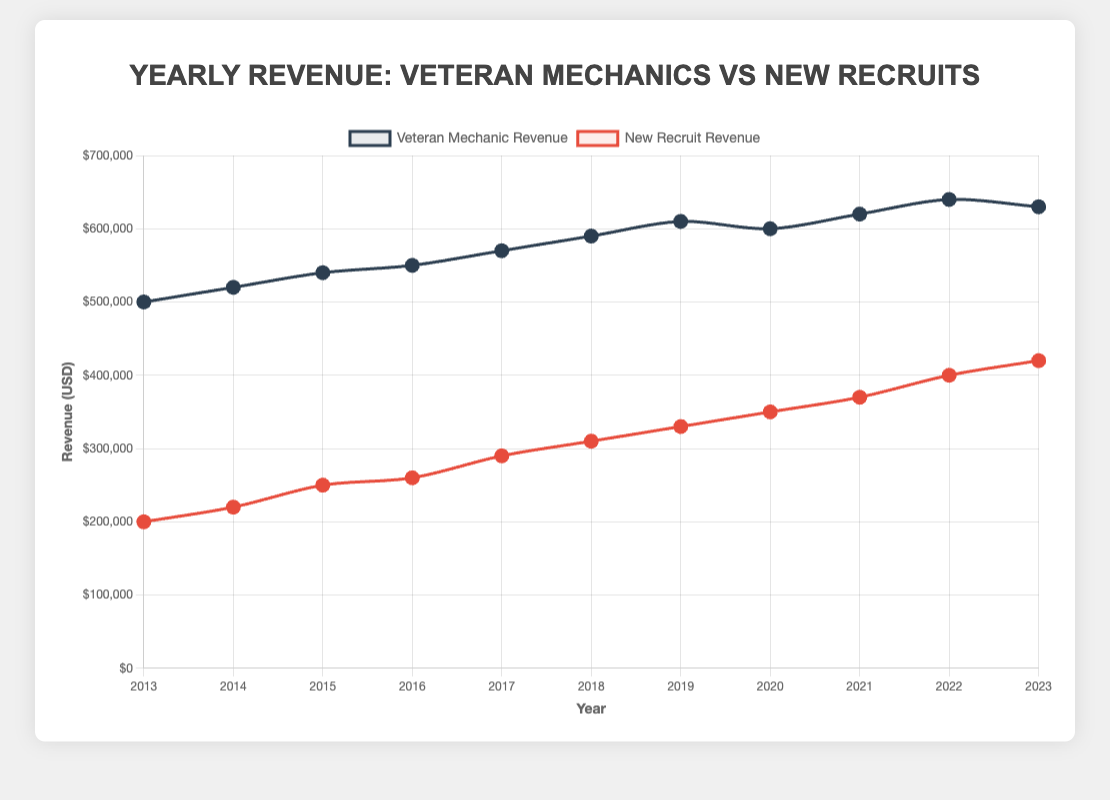Which year had the highest yearly revenue for veteran mechanics? To determine this, look at the peaks in the plot for veteran mechanics, which is represented in dark blue. The highest point reaches $640,000 in 2022.
Answer: 2022 Which group had a higher revenue in 2017, veteran mechanics or new recruits? Locate the points on the plot corresponding to 2017 for both lines. The dark blue line (veteran mechanics) is at $570,000 whereas the red line (new recruits) is at $290,000.
Answer: Veteran mechanics By how much did the revenue of new recruits increase from 2013 to 2023? Observe the values for new recruits in 2013 ($200,000) and 2023 ($420,000). Subtract the earlier year from the later year: $420,000 - $200,000 = $220,000.
Answer: $220,000 What's the average revenue generated by veteran mechanics over the 10-year span from 2013 to 2023? Calculate the sum of the yearly revenues for veteran mechanics over the specified years, and then divide by the number of years (11): (500,000 + 520,000 + 540,000 + 550,000 + 570,000 + 590,000 + 610,000 + 600,000 + 620,000 + 640,000 + 630,000) / 11 = 594,545.45.
Answer: $594,545.45 In which year was the revenue difference between veteran mechanics and new recruits the smallest? Compare the difference in revenue between the two groups each year: (sum for each year) 2013: 300,000; 2014: 300,000; 2015: 290,000; 2016: 290,000; 2017: 280,000; 2018: 280,000; 2019: 280,000; 2020: 250,000; 2021: 250,000; 2022: 240,000; 2023: 210,000. The smallest difference is in 2023 at $210,000.
Answer: 2023 Did veteran mechanic revenue ever decrease from one year to the next? If so, when? Check the veteran mechanics' revenue data for downward trends. The revenue decreased from 2019 ($610,000) to 2020 ($600,000) and from 2022 ($640,000) to 2023 ($630,000).
Answer: Yes, 2019 to 2020 and 2022 to 2023 What was the revenue trend for new recruits from 2016 to 2023? Observe the plot for new recruits from 2016 to 2023. Each year, the revenue values increase consistently: $260,000 in 2016, up to $420,000 in 2023.
Answer: Consistently increasing How much total revenue did new recruits generate from 2018 to 2023? Add revenue values for the years in question: $310,000 + $330,000 + $350,000 + $370,000 + $400,000 + $420,000 = $2,180,000.
Answer: $2,180,000 